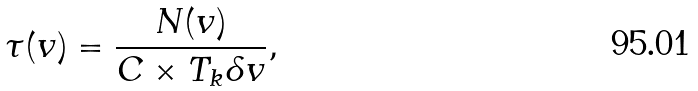<formula> <loc_0><loc_0><loc_500><loc_500>\tau ( v ) = \frac { N ( v ) } { C \times T _ { k } \delta v } ,</formula> 